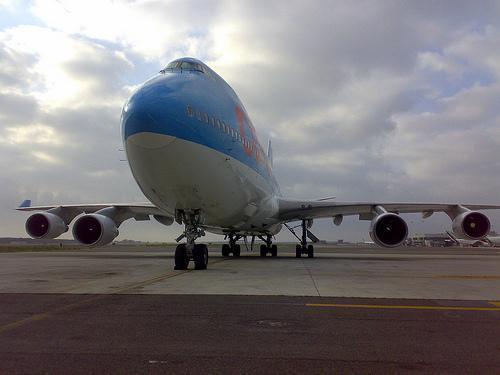How many planes?
Give a very brief answer. 1. 